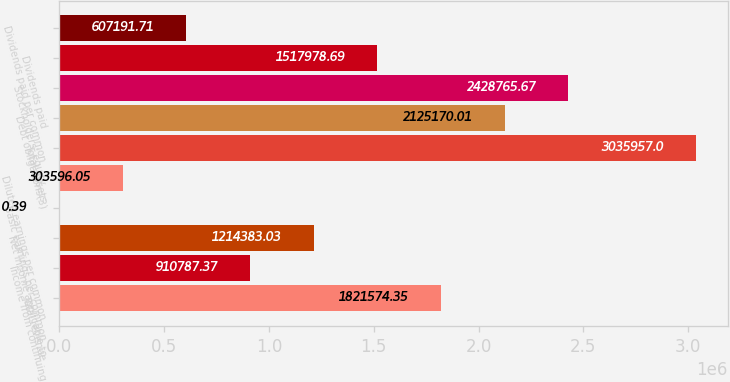Convert chart to OTSL. <chart><loc_0><loc_0><loc_500><loc_500><bar_chart><fcel>Total revenue<fcel>Income from continuing<fcel>Net income applicable to<fcel>Basic earnings per common<fcel>Diluted earnings per common<fcel>Total assets<fcel>Debt obligations(3)<fcel>Stockholders' equity<fcel>Dividends paid<fcel>Dividends paid per common<nl><fcel>1.82157e+06<fcel>910787<fcel>1.21438e+06<fcel>0.39<fcel>303596<fcel>3.03596e+06<fcel>2.12517e+06<fcel>2.42877e+06<fcel>1.51798e+06<fcel>607192<nl></chart> 